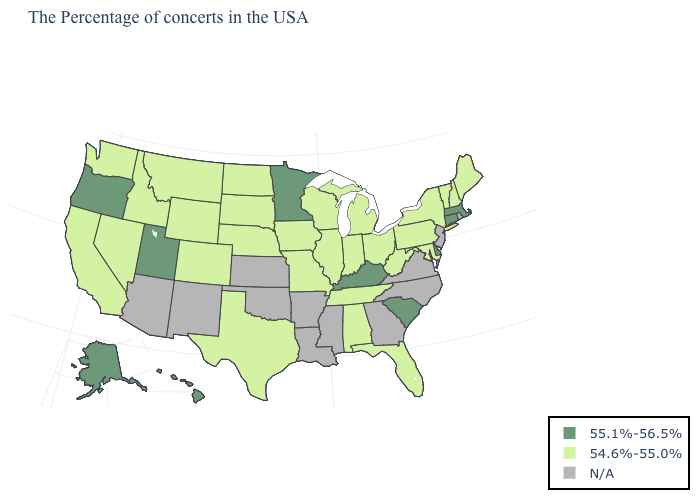What is the value of Texas?
Concise answer only. 54.6%-55.0%. What is the value of South Carolina?
Keep it brief. 55.1%-56.5%. Among the states that border South Dakota , which have the highest value?
Short answer required. Minnesota. Does the map have missing data?
Answer briefly. Yes. Does South Carolina have the lowest value in the South?
Write a very short answer. No. Does West Virginia have the lowest value in the USA?
Give a very brief answer. Yes. What is the value of Tennessee?
Quick response, please. 54.6%-55.0%. What is the value of Illinois?
Give a very brief answer. 54.6%-55.0%. Does South Carolina have the highest value in the South?
Concise answer only. Yes. Which states have the highest value in the USA?
Be succinct. Massachusetts, Connecticut, Delaware, South Carolina, Kentucky, Minnesota, Utah, Oregon, Alaska, Hawaii. Which states have the lowest value in the South?
Write a very short answer. Maryland, West Virginia, Florida, Alabama, Tennessee, Texas. What is the highest value in the USA?
Keep it brief. 55.1%-56.5%. 